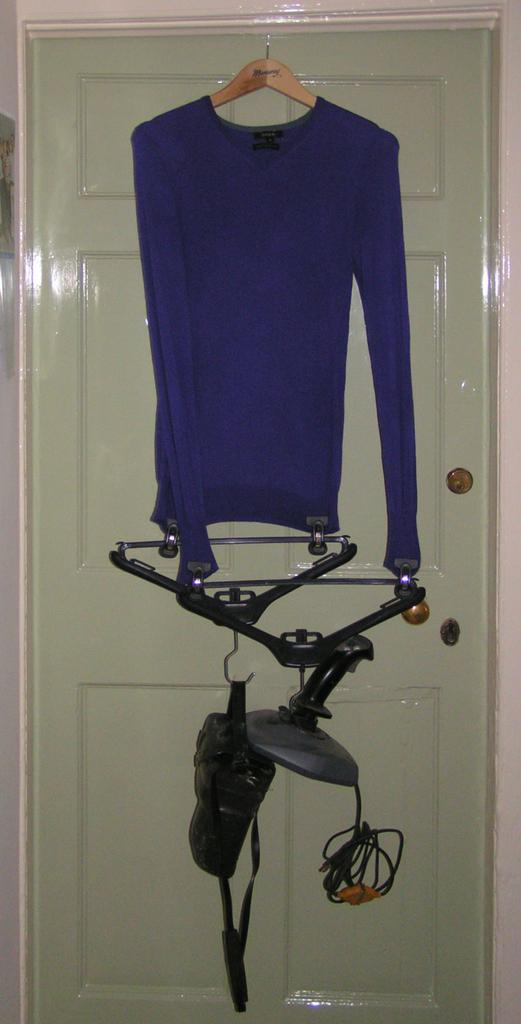What type of clothing is hanging on the hanger in the image? There are blue t-shirts hanging on a hanger in the image. Where are the hangers located in the image? The hangers are on a door in the image. What object is visible on the door in the image? A camera is visible on the door in the image. What is beside the door in the image? There is a wall beside the door in the image. What type of leather is used to make the t-shirts in the image? The t-shirts in the image are not made of leather; they are made of fabric. 